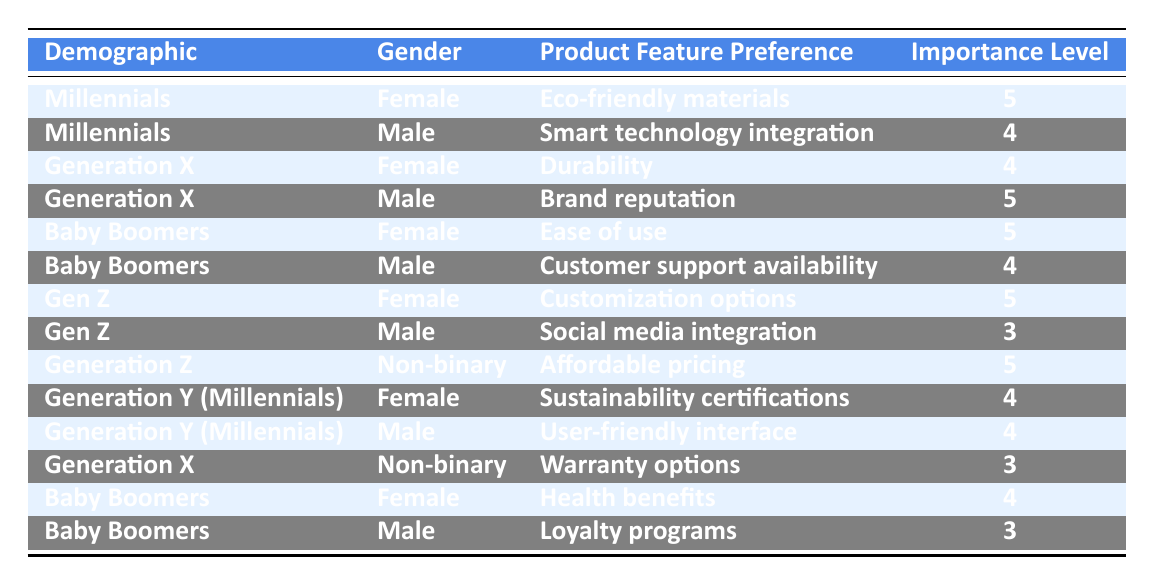What is the product feature preference of Baby Boomers who are female? From the table, we find the row for Baby Boomers and female. The corresponding product feature preference listed is "Ease of use."
Answer: Ease of use Which demographic has the highest importance level for product feature preferences? We review the importance levels in the table. The highest level is 5, which appears multiple times across different demographics: Millennials (Female), Generation X (Male), Baby Boomers (Female), Gen Z (Female), and Generation Z (Non-binary).
Answer: Millennials, Generation X, Baby Boomers, Gen Z, Generation Z Is "Smart technology integration" preferred by more males or females in the Millennials demographic? In the table, we identify that "Smart technology integration" is listed under the Millennials demographic for males only, while for females, "Eco-friendly materials" is shown. Therefore, "Smart technology integration" is preferred by males in this instance.
Answer: Males What are the importance levels for customization options among Generation Z females? The entry for Generation Z (Female) indicates an importance level of 5 for "Customization options." This is a single data point specific to that demographic and feature.
Answer: 5 What is the average importance level of product feature preferences for Baby Boomers? To calculate this, we identify the importance levels for Baby Boomers: 5 (Ease of use), 4 (Customer support availability), 4 (Health benefits), and 3 (Loyalty programs). The sum is 5 + 4 + 4 + 3 = 16, and there are 4 data points, so the average is 16/4 = 4.
Answer: 4 Which demographic has the lowest importance level for product features, and what are the specifics? The table reveals that both "Social media integration" (Gen Z, Male) and "Warranty options" (Generation X, Non-binary), along with "Loyalty programs" (Baby Boomers, Male), have an importance level of 3, which are the lowest.
Answer: Gen Z, Male / Generation X, Non-binary / Baby Boomers, Male Are there any "Eco-friendly materials" preferences among Generation X? Looking at the table, "Eco-friendly materials" is specifically listed under the Millennials (Female) and not under Generation X. This means there are no preferences for "Eco-friendly materials" among Generation X.
Answer: No How does the Importance Level of Customer support availability compare with the average importance level of Millennials' preferences? The importance level for "Customer support availability" is 4 for Baby Boomers (Male). For Millennials, if we compute the importance levels: 5 (Eco-friendly materials) and 4 (Smart technology integration), we find they average to 4.5 ( (5+4)/2 ). Thus, 4 for customer support is lower than the average for Millennials.
Answer: Lower What feature gets the highest rating from Generation Y (Millennials) male? The table shows that "User-friendly interface" is listed under Generation Y (Millennials) for males with an importance level of 4. This is the highest preference score noted for males in that demographic.
Answer: User-friendly interface 